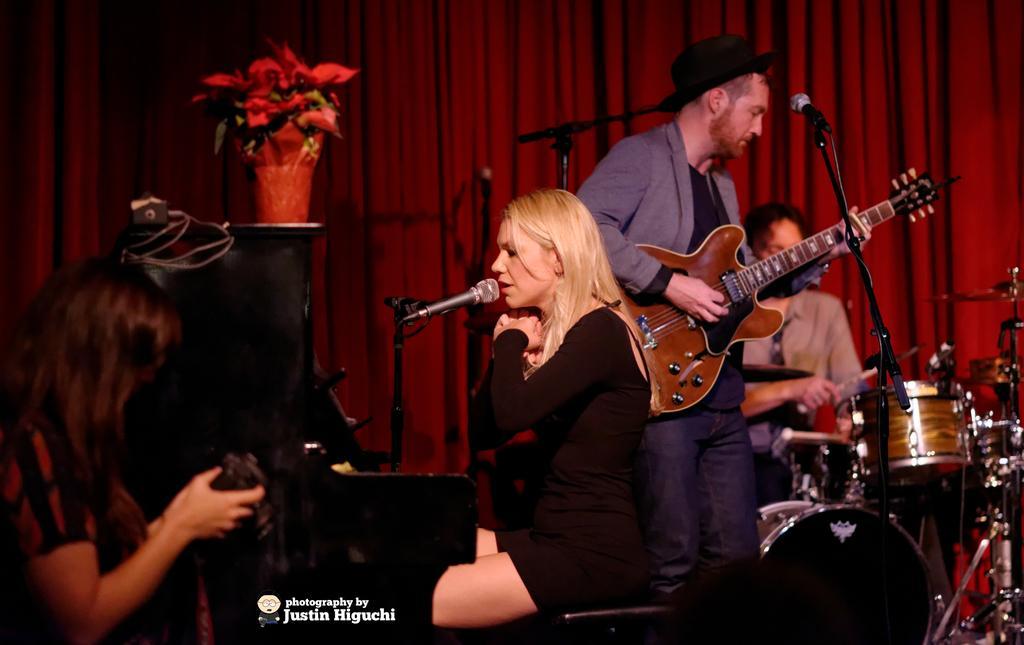How would you summarize this image in a sentence or two? This picture is taken in a room, There are some music instrument which are in yellow and black color. In the left side there is a woman holding a camera and taking a pic, In the middle there is a woman wearing a black coat singing in a microphone, In the right side there is a man standing and holding a music instrument which is in yellow color, In the background there is a red color curtain and in the right side there is a red color flower wash. 